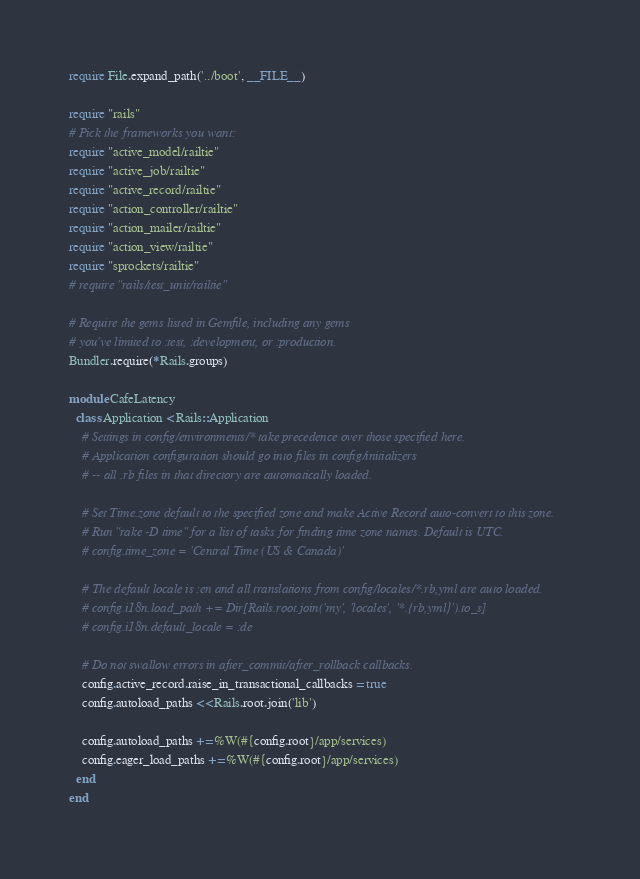<code> <loc_0><loc_0><loc_500><loc_500><_Ruby_>require File.expand_path('../boot', __FILE__)

require "rails"
# Pick the frameworks you want:
require "active_model/railtie"
require "active_job/railtie"
require "active_record/railtie"
require "action_controller/railtie"
require "action_mailer/railtie"
require "action_view/railtie"
require "sprockets/railtie"
# require "rails/test_unit/railtie"

# Require the gems listed in Gemfile, including any gems
# you've limited to :test, :development, or :production.
Bundler.require(*Rails.groups)

module CafeLatency
  class Application < Rails::Application
    # Settings in config/environments/* take precedence over those specified here.
    # Application configuration should go into files in config/initializers
    # -- all .rb files in that directory are automatically loaded.

    # Set Time.zone default to the specified zone and make Active Record auto-convert to this zone.
    # Run "rake -D time" for a list of tasks for finding time zone names. Default is UTC.
    # config.time_zone = 'Central Time (US & Canada)'

    # The default locale is :en and all translations from config/locales/*.rb,yml are auto loaded.
    # config.i18n.load_path += Dir[Rails.root.join('my', 'locales', '*.{rb,yml}').to_s]
    # config.i18n.default_locale = :de

    # Do not swallow errors in after_commit/after_rollback callbacks.
    config.active_record.raise_in_transactional_callbacks = true
    config.autoload_paths << Rails.root.join('lib')

    config.autoload_paths += %W(#{config.root}/app/services)
    config.eager_load_paths += %W(#{config.root}/app/services)
  end
end
</code> 